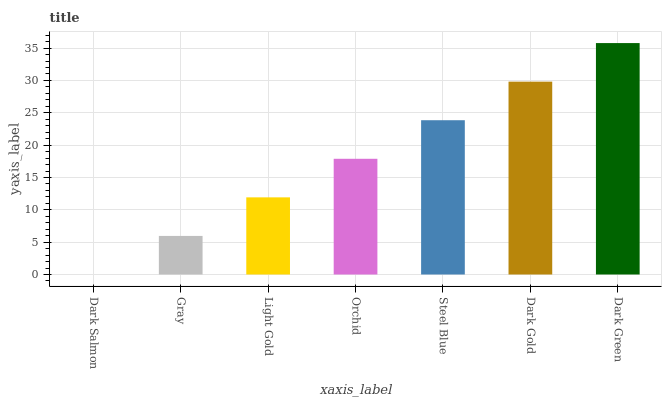Is Dark Salmon the minimum?
Answer yes or no. Yes. Is Dark Green the maximum?
Answer yes or no. Yes. Is Gray the minimum?
Answer yes or no. No. Is Gray the maximum?
Answer yes or no. No. Is Gray greater than Dark Salmon?
Answer yes or no. Yes. Is Dark Salmon less than Gray?
Answer yes or no. Yes. Is Dark Salmon greater than Gray?
Answer yes or no. No. Is Gray less than Dark Salmon?
Answer yes or no. No. Is Orchid the high median?
Answer yes or no. Yes. Is Orchid the low median?
Answer yes or no. Yes. Is Steel Blue the high median?
Answer yes or no. No. Is Dark Salmon the low median?
Answer yes or no. No. 